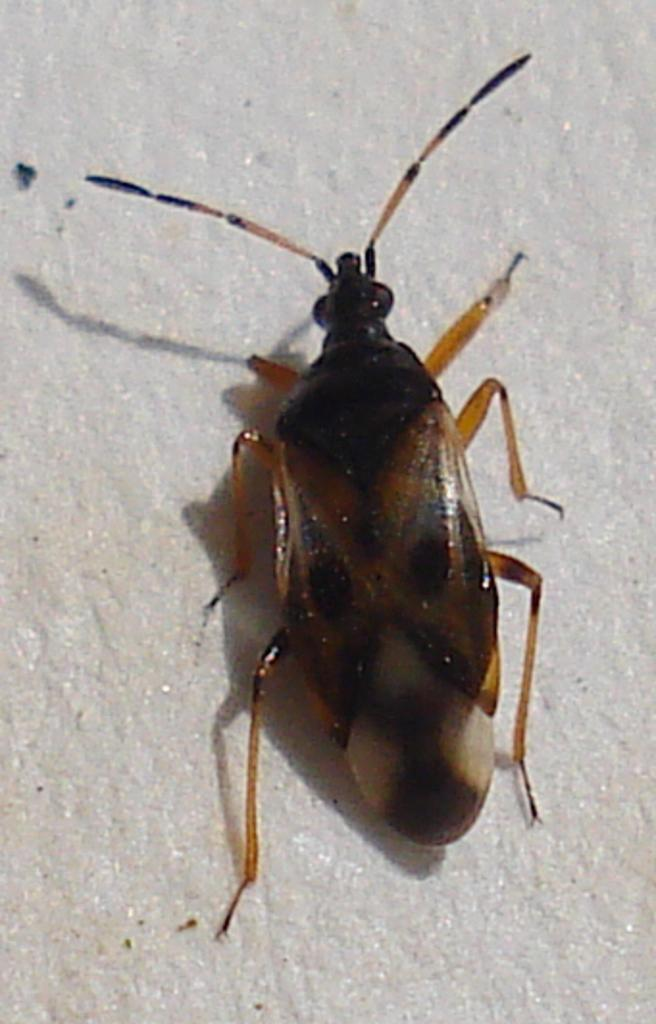What type of creature is present in the image? There is an insect in the image. Can you describe the insect's location in the image? The insect is on a surface in the image. What month is depicted in the image? There is no indication of a specific month in the image, as it only features an insect on a surface. What type of furniture is present in the image? There is no furniture present in the image; it only features an insect on a surface. 